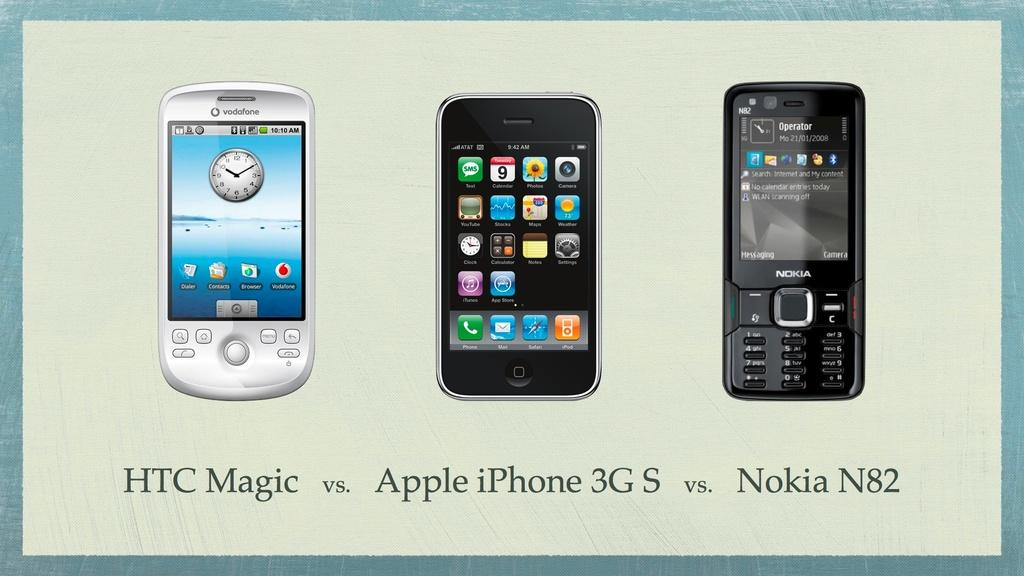<image>
Give a short and clear explanation of the subsequent image. Three smart phones are next to each other and it says HTC Magic vs. Apple iPhone 3G S vs. Nokia N82 beneath them. 